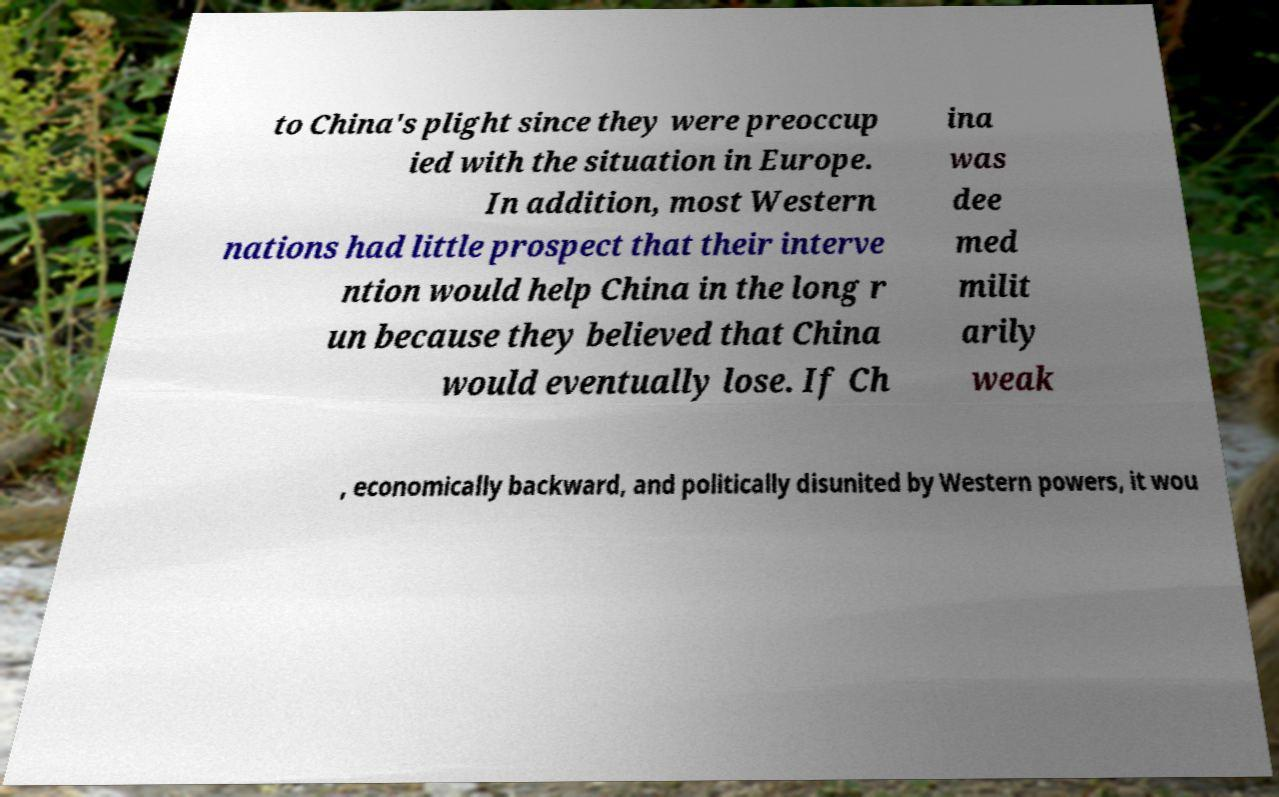For documentation purposes, I need the text within this image transcribed. Could you provide that? to China's plight since they were preoccup ied with the situation in Europe. In addition, most Western nations had little prospect that their interve ntion would help China in the long r un because they believed that China would eventually lose. If Ch ina was dee med milit arily weak , economically backward, and politically disunited by Western powers, it wou 